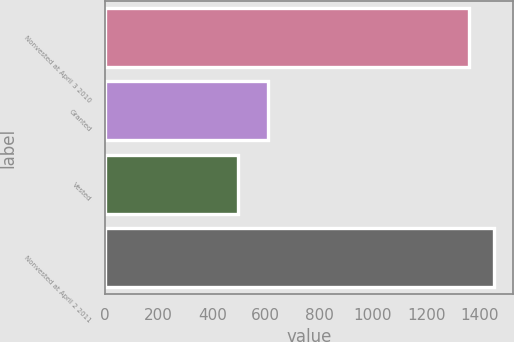Convert chart. <chart><loc_0><loc_0><loc_500><loc_500><bar_chart><fcel>Nonvested at April 3 2010<fcel>Granted<fcel>Vested<fcel>Nonvested at April 2 2011<nl><fcel>1359<fcel>607<fcel>496<fcel>1451<nl></chart> 